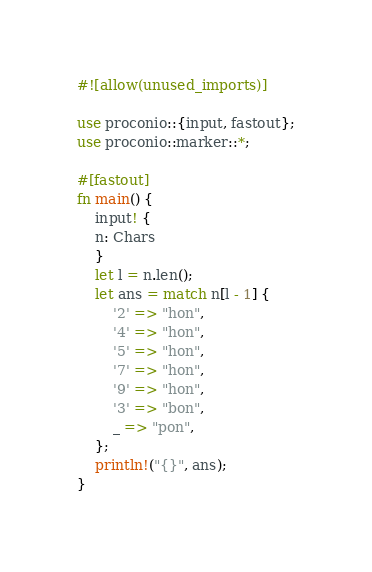<code> <loc_0><loc_0><loc_500><loc_500><_Rust_>#![allow(unused_imports)]

use proconio::{input, fastout};
use proconio::marker::*;

#[fastout]
fn main() {
    input! {
    n: Chars
    }
    let l = n.len();
    let ans = match n[l - 1] {
        '2' => "hon",
        '4' => "hon",
        '5' => "hon",
        '7' => "hon",
        '9' => "hon",
        '3' => "bon",
        _ => "pon",
    };
    println!("{}", ans);
}
</code> 